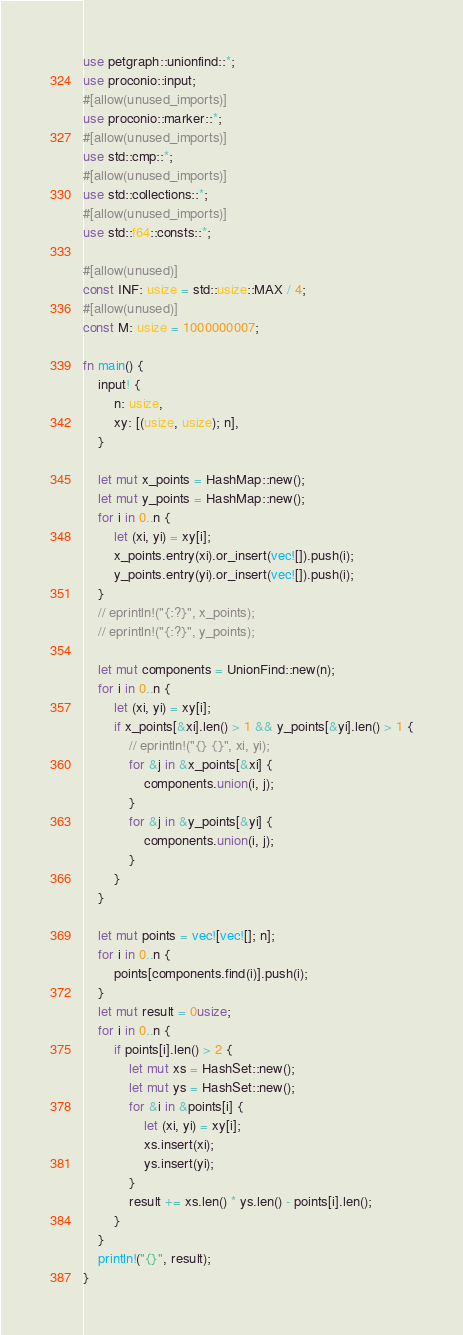<code> <loc_0><loc_0><loc_500><loc_500><_Rust_>use petgraph::unionfind::*;
use proconio::input;
#[allow(unused_imports)]
use proconio::marker::*;
#[allow(unused_imports)]
use std::cmp::*;
#[allow(unused_imports)]
use std::collections::*;
#[allow(unused_imports)]
use std::f64::consts::*;

#[allow(unused)]
const INF: usize = std::usize::MAX / 4;
#[allow(unused)]
const M: usize = 1000000007;

fn main() {
    input! {
        n: usize,
        xy: [(usize, usize); n],
    }

    let mut x_points = HashMap::new();
    let mut y_points = HashMap::new();
    for i in 0..n {
        let (xi, yi) = xy[i];
        x_points.entry(xi).or_insert(vec![]).push(i);
        y_points.entry(yi).or_insert(vec![]).push(i);
    }
    // eprintln!("{:?}", x_points);
    // eprintln!("{:?}", y_points);

    let mut components = UnionFind::new(n);
    for i in 0..n {
        let (xi, yi) = xy[i];
        if x_points[&xi].len() > 1 && y_points[&yi].len() > 1 {
            // eprintln!("{} {}", xi, yi);
            for &j in &x_points[&xi] {
                components.union(i, j);
            }
            for &j in &y_points[&yi] {
                components.union(i, j);
            }
        }
    }

    let mut points = vec![vec![]; n];
    for i in 0..n {
        points[components.find(i)].push(i);
    }
    let mut result = 0usize;
    for i in 0..n {
        if points[i].len() > 2 {
            let mut xs = HashSet::new();
            let mut ys = HashSet::new();
            for &i in &points[i] {
                let (xi, yi) = xy[i];
                xs.insert(xi);
                ys.insert(yi);
            }
            result += xs.len() * ys.len() - points[i].len();
        }
    }
    println!("{}", result);
}
</code> 